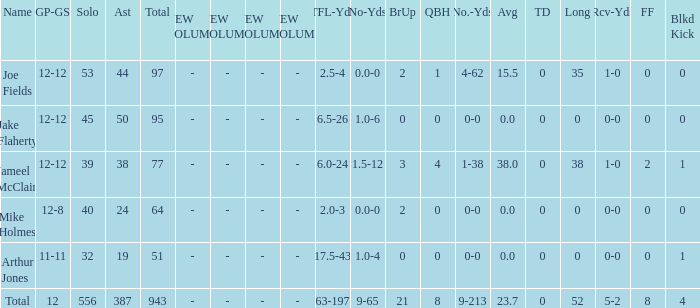What is the total brup for the team? 21.0. 